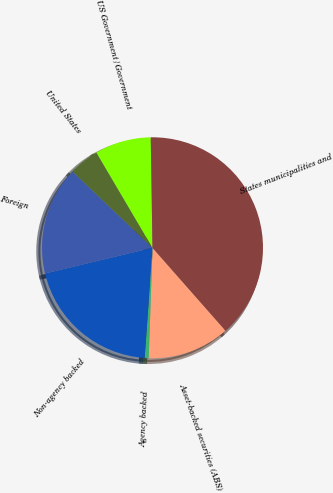<chart> <loc_0><loc_0><loc_500><loc_500><pie_chart><fcel>Asset-backed securities (ABS)<fcel>Agency backed<fcel>Non-agency backed<fcel>Foreign<fcel>United States<fcel>US Government/Government<fcel>States municipalities and<nl><fcel>12.04%<fcel>0.59%<fcel>20.12%<fcel>15.86%<fcel>4.41%<fcel>8.22%<fcel>38.76%<nl></chart> 